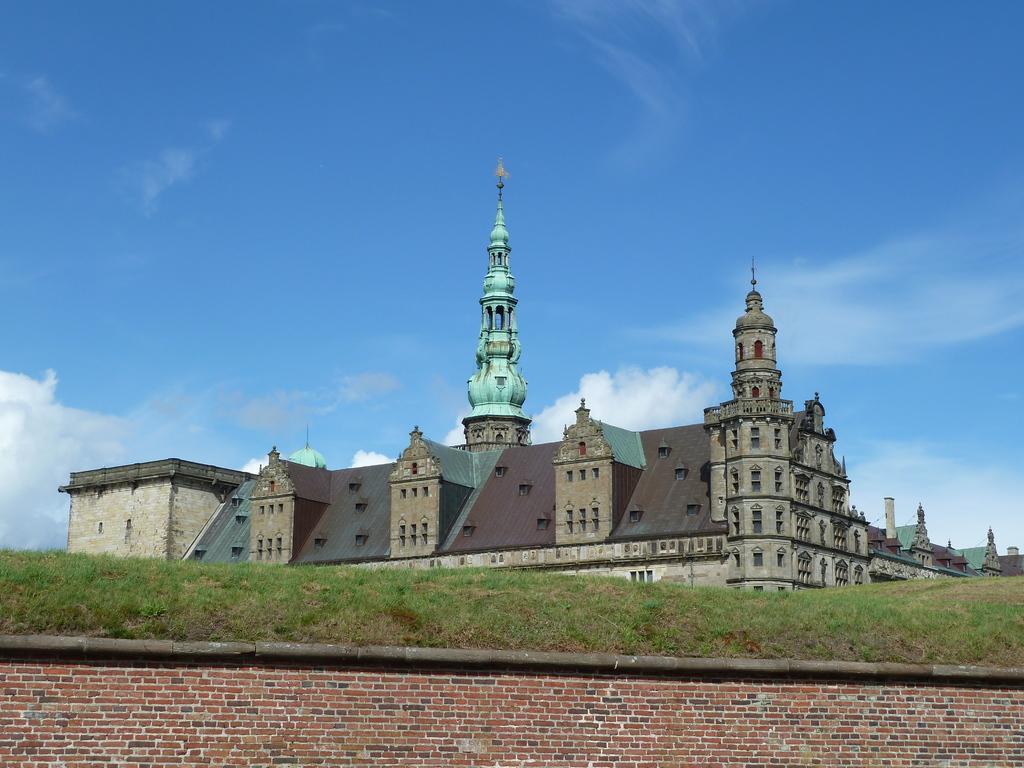Can you describe this image briefly? At the bottom of the image there is a brick wall. Above the wall there's grass on the ground. And also there is a building with walls, windows, roofs and poles. In the background there is sky. 